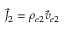<formula> <loc_0><loc_0><loc_500><loc_500>\vec { J } _ { 2 } = \rho _ { e 2 } \vec { v } _ { e 2 }</formula> 